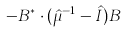Convert formula to latex. <formula><loc_0><loc_0><loc_500><loc_500>- { B } ^ { * } \cdot ( \hat { \mu } ^ { - 1 } - \hat { I } ) { B }</formula> 